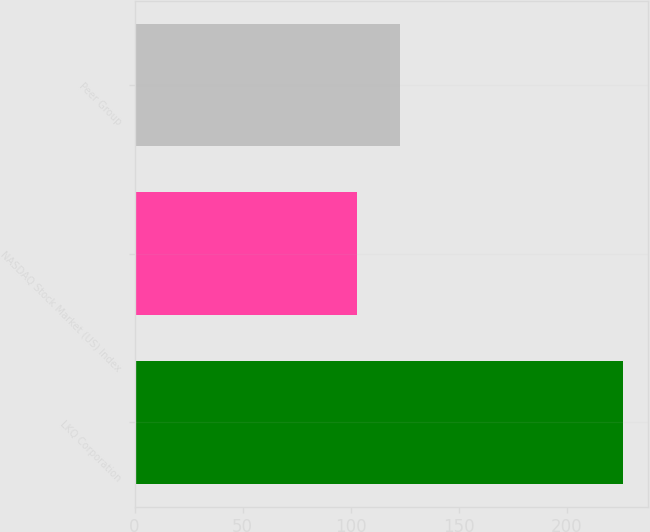Convert chart. <chart><loc_0><loc_0><loc_500><loc_500><bar_chart><fcel>LKQ Corporation<fcel>NASDAQ Stock Market (US) Index<fcel>Peer Group<nl><fcel>226<fcel>103<fcel>123<nl></chart> 